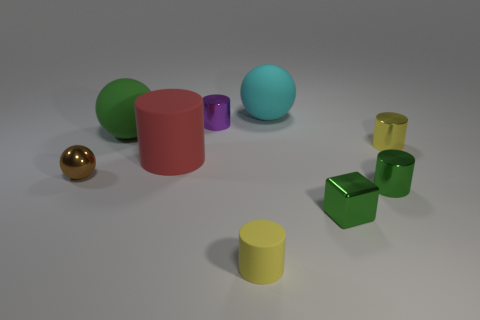Are there fewer large cyan balls that are right of the large cyan sphere than green shiny cylinders?
Ensure brevity in your answer.  Yes. Is there any other thing that has the same shape as the big cyan matte thing?
Offer a very short reply. Yes. Are there any big cyan metallic things?
Give a very brief answer. No. Is the number of big cyan metallic things less than the number of cyan rubber balls?
Your answer should be compact. Yes. How many tiny cylinders have the same material as the small purple object?
Provide a short and direct response. 2. There is another cylinder that is the same material as the large red cylinder; what is its color?
Your response must be concise. Yellow. The big cyan thing has what shape?
Offer a very short reply. Sphere. How many tiny rubber objects have the same color as the tiny ball?
Keep it short and to the point. 0. There is a yellow shiny thing that is the same size as the brown object; what is its shape?
Keep it short and to the point. Cylinder. Are there any purple cylinders of the same size as the yellow rubber cylinder?
Make the answer very short. Yes. 